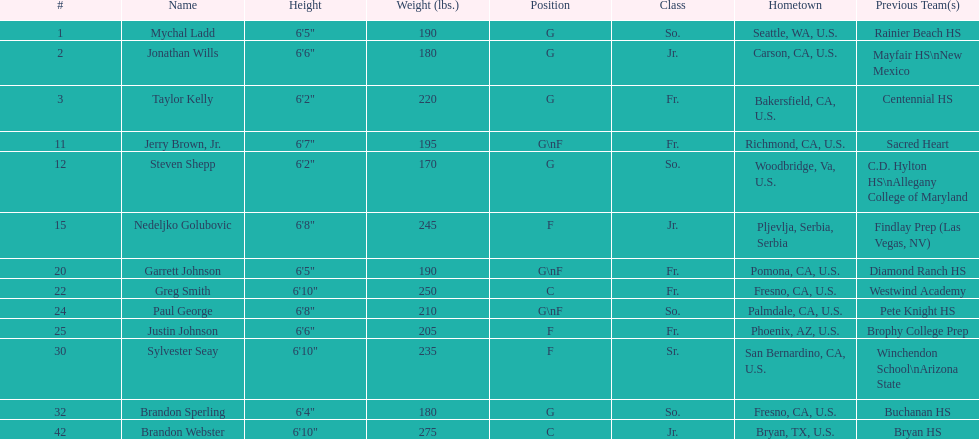Identify the only player who is not from the u.s. Nedeljko Golubovic. 